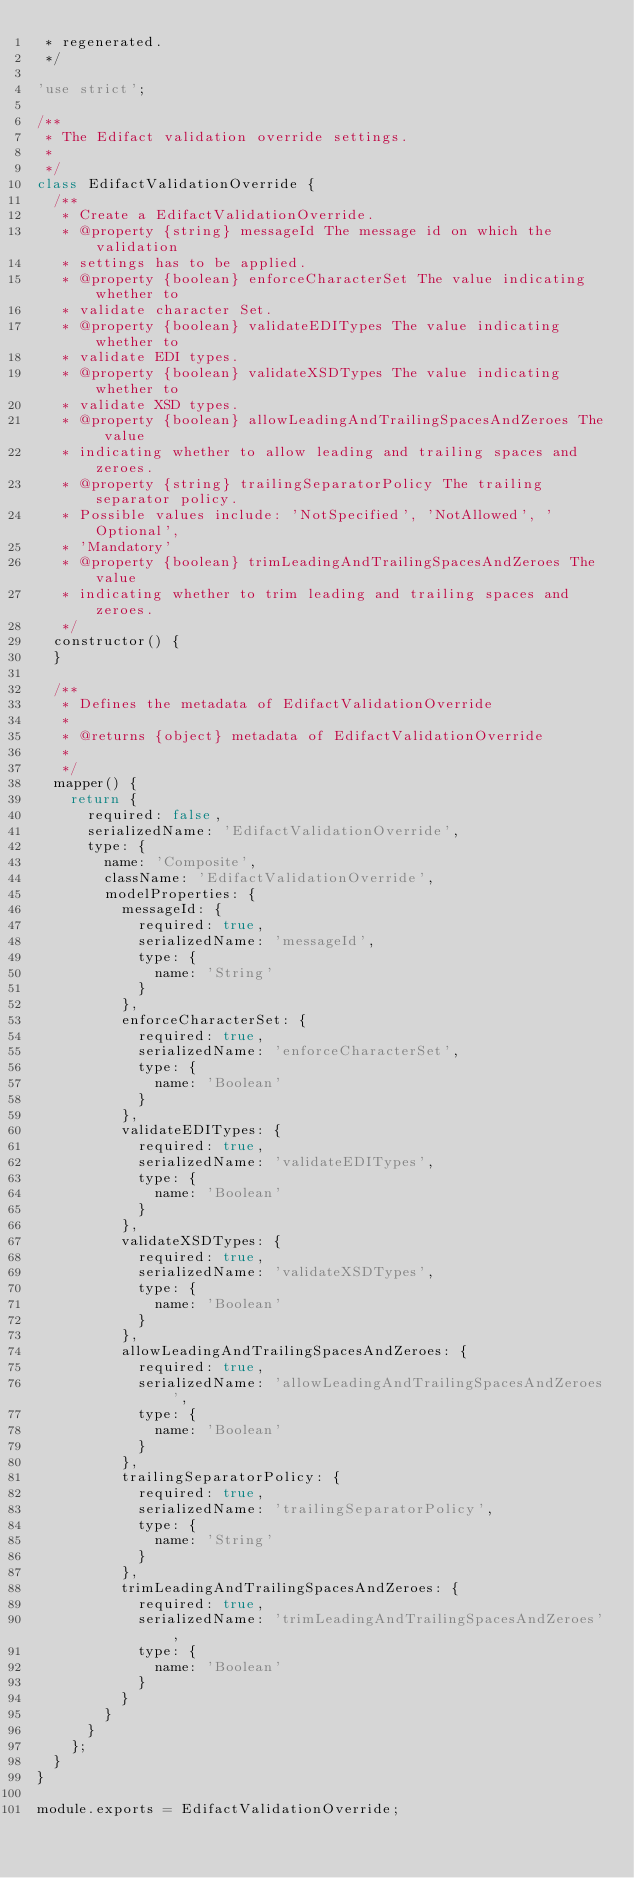<code> <loc_0><loc_0><loc_500><loc_500><_JavaScript_> * regenerated.
 */

'use strict';

/**
 * The Edifact validation override settings.
 *
 */
class EdifactValidationOverride {
  /**
   * Create a EdifactValidationOverride.
   * @property {string} messageId The message id on which the validation
   * settings has to be applied.
   * @property {boolean} enforceCharacterSet The value indicating whether to
   * validate character Set.
   * @property {boolean} validateEDITypes The value indicating whether to
   * validate EDI types.
   * @property {boolean} validateXSDTypes The value indicating whether to
   * validate XSD types.
   * @property {boolean} allowLeadingAndTrailingSpacesAndZeroes The value
   * indicating whether to allow leading and trailing spaces and zeroes.
   * @property {string} trailingSeparatorPolicy The trailing separator policy.
   * Possible values include: 'NotSpecified', 'NotAllowed', 'Optional',
   * 'Mandatory'
   * @property {boolean} trimLeadingAndTrailingSpacesAndZeroes The value
   * indicating whether to trim leading and trailing spaces and zeroes.
   */
  constructor() {
  }

  /**
   * Defines the metadata of EdifactValidationOverride
   *
   * @returns {object} metadata of EdifactValidationOverride
   *
   */
  mapper() {
    return {
      required: false,
      serializedName: 'EdifactValidationOverride',
      type: {
        name: 'Composite',
        className: 'EdifactValidationOverride',
        modelProperties: {
          messageId: {
            required: true,
            serializedName: 'messageId',
            type: {
              name: 'String'
            }
          },
          enforceCharacterSet: {
            required: true,
            serializedName: 'enforceCharacterSet',
            type: {
              name: 'Boolean'
            }
          },
          validateEDITypes: {
            required: true,
            serializedName: 'validateEDITypes',
            type: {
              name: 'Boolean'
            }
          },
          validateXSDTypes: {
            required: true,
            serializedName: 'validateXSDTypes',
            type: {
              name: 'Boolean'
            }
          },
          allowLeadingAndTrailingSpacesAndZeroes: {
            required: true,
            serializedName: 'allowLeadingAndTrailingSpacesAndZeroes',
            type: {
              name: 'Boolean'
            }
          },
          trailingSeparatorPolicy: {
            required: true,
            serializedName: 'trailingSeparatorPolicy',
            type: {
              name: 'String'
            }
          },
          trimLeadingAndTrailingSpacesAndZeroes: {
            required: true,
            serializedName: 'trimLeadingAndTrailingSpacesAndZeroes',
            type: {
              name: 'Boolean'
            }
          }
        }
      }
    };
  }
}

module.exports = EdifactValidationOverride;
</code> 